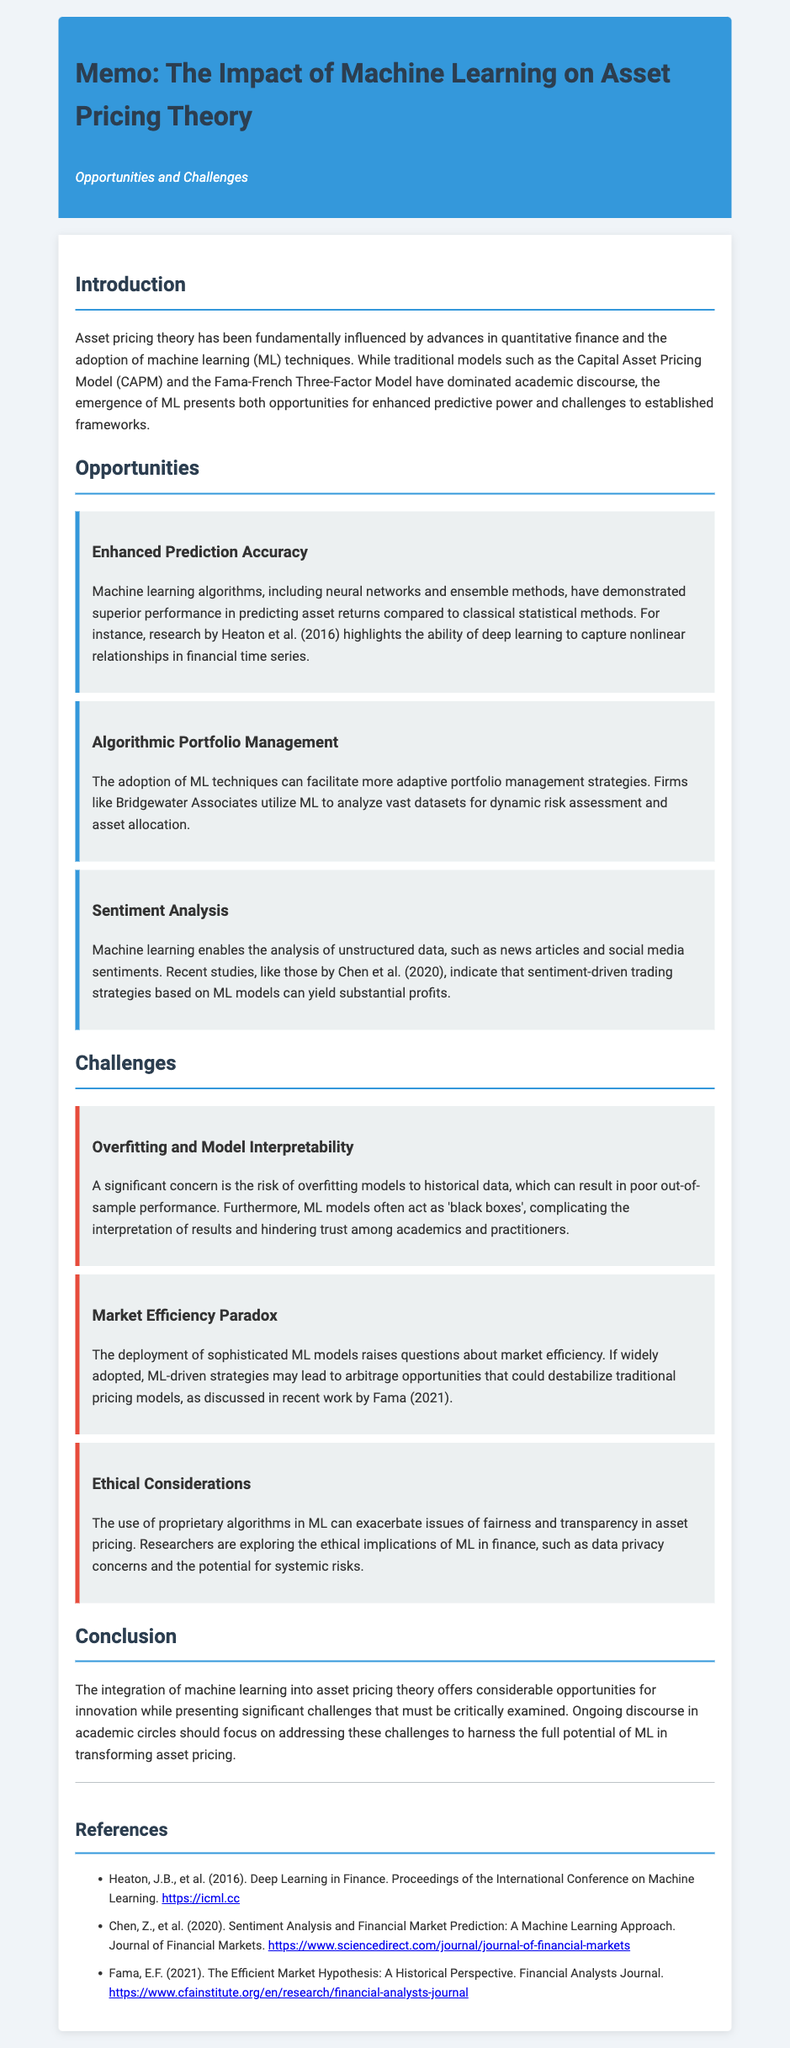What are the traditional models mentioned? The document mentions the Capital Asset Pricing Model (CAPM) and the Fama-French Three-Factor Model as traditional models.
Answer: CAPM and Fama-French Three-Factor Model Who conducted the research on deep learning's predictive ability? The document cites research by Heaton et al. (2016) regarding deep learning's ability to capture nonlinear relationships in financial time series.
Answer: Heaton et al. (2016) What is a major concern regarding machine learning models? The document highlights overfitting and model interpretability as significant concerns in using machine learning.
Answer: Overfitting and model interpretability Which firm is mentioned as utilizing machine learning for portfolio management? The memo refers to Bridgewater Associates as a firm that uses machine learning for portfolio management strategies.
Answer: Bridgewater Associates What ethical consideration is discussed in relation to ML in finance? The document discusses issues of fairness and transparency as ethical considerations in the use of proprietary algorithms in ML.
Answer: Fairness and transparency What is the primary focus of ongoing discourse in academic circles according to the conclusion? The memo states that ongoing discourse should focus on addressing challenges to harness the full potential of machine learning in asset pricing.
Answer: Addressing challenges Which study explores sentiment-driven trading strategies? The document references a study by Chen et al. (2020) that investigates sentiment-driven trading strategies based on machine learning.
Answer: Chen et al. (2020) What paradox is raised by the deployment of ML models? The document mentions the market efficiency paradox as a concern related to the deployment of sophisticated machine learning models.
Answer: Market efficiency paradox Which method is noted for enhancing prediction accuracy? The memo identifies machine learning algorithms, including neural networks and ensemble methods, as methods that enhance prediction accuracy.
Answer: Neural networks and ensemble methods 